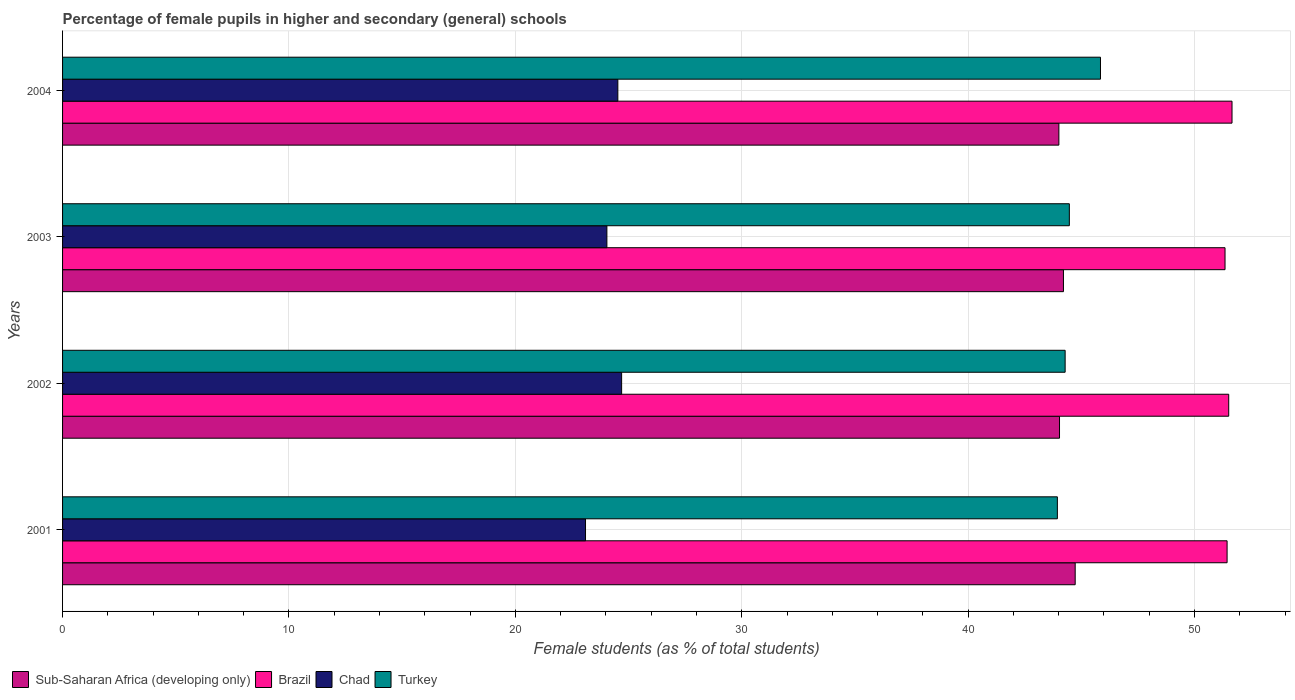How many bars are there on the 2nd tick from the bottom?
Offer a very short reply. 4. What is the percentage of female pupils in higher and secondary schools in Sub-Saharan Africa (developing only) in 2004?
Ensure brevity in your answer.  44.01. Across all years, what is the maximum percentage of female pupils in higher and secondary schools in Brazil?
Give a very brief answer. 51.66. Across all years, what is the minimum percentage of female pupils in higher and secondary schools in Chad?
Offer a very short reply. 23.1. In which year was the percentage of female pupils in higher and secondary schools in Turkey maximum?
Provide a succinct answer. 2004. What is the total percentage of female pupils in higher and secondary schools in Chad in the graph?
Your response must be concise. 96.37. What is the difference between the percentage of female pupils in higher and secondary schools in Turkey in 2002 and that in 2003?
Offer a terse response. -0.19. What is the difference between the percentage of female pupils in higher and secondary schools in Sub-Saharan Africa (developing only) in 2001 and the percentage of female pupils in higher and secondary schools in Brazil in 2003?
Your answer should be compact. -6.62. What is the average percentage of female pupils in higher and secondary schools in Brazil per year?
Your response must be concise. 51.49. In the year 2004, what is the difference between the percentage of female pupils in higher and secondary schools in Turkey and percentage of female pupils in higher and secondary schools in Brazil?
Ensure brevity in your answer.  -5.81. In how many years, is the percentage of female pupils in higher and secondary schools in Brazil greater than 2 %?
Give a very brief answer. 4. What is the ratio of the percentage of female pupils in higher and secondary schools in Brazil in 2003 to that in 2004?
Your answer should be compact. 0.99. Is the percentage of female pupils in higher and secondary schools in Turkey in 2001 less than that in 2002?
Your answer should be compact. Yes. Is the difference between the percentage of female pupils in higher and secondary schools in Turkey in 2002 and 2003 greater than the difference between the percentage of female pupils in higher and secondary schools in Brazil in 2002 and 2003?
Your answer should be compact. No. What is the difference between the highest and the second highest percentage of female pupils in higher and secondary schools in Chad?
Your answer should be compact. 0.17. What is the difference between the highest and the lowest percentage of female pupils in higher and secondary schools in Sub-Saharan Africa (developing only)?
Offer a terse response. 0.72. Is the sum of the percentage of female pupils in higher and secondary schools in Chad in 2002 and 2003 greater than the maximum percentage of female pupils in higher and secondary schools in Brazil across all years?
Keep it short and to the point. No. Is it the case that in every year, the sum of the percentage of female pupils in higher and secondary schools in Sub-Saharan Africa (developing only) and percentage of female pupils in higher and secondary schools in Turkey is greater than the sum of percentage of female pupils in higher and secondary schools in Chad and percentage of female pupils in higher and secondary schools in Brazil?
Your answer should be compact. No. What does the 2nd bar from the top in 2001 represents?
Offer a very short reply. Chad. What does the 4th bar from the bottom in 2003 represents?
Your answer should be very brief. Turkey. Is it the case that in every year, the sum of the percentage of female pupils in higher and secondary schools in Chad and percentage of female pupils in higher and secondary schools in Turkey is greater than the percentage of female pupils in higher and secondary schools in Brazil?
Keep it short and to the point. Yes. What is the difference between two consecutive major ticks on the X-axis?
Ensure brevity in your answer.  10. Does the graph contain any zero values?
Provide a short and direct response. No. Does the graph contain grids?
Provide a short and direct response. Yes. What is the title of the graph?
Give a very brief answer. Percentage of female pupils in higher and secondary (general) schools. What is the label or title of the X-axis?
Make the answer very short. Female students (as % of total students). What is the label or title of the Y-axis?
Provide a short and direct response. Years. What is the Female students (as % of total students) of Sub-Saharan Africa (developing only) in 2001?
Give a very brief answer. 44.73. What is the Female students (as % of total students) in Brazil in 2001?
Provide a short and direct response. 51.44. What is the Female students (as % of total students) in Chad in 2001?
Make the answer very short. 23.1. What is the Female students (as % of total students) in Turkey in 2001?
Give a very brief answer. 43.94. What is the Female students (as % of total students) of Sub-Saharan Africa (developing only) in 2002?
Your answer should be very brief. 44.04. What is the Female students (as % of total students) of Brazil in 2002?
Provide a short and direct response. 51.51. What is the Female students (as % of total students) in Chad in 2002?
Ensure brevity in your answer.  24.69. What is the Female students (as % of total students) in Turkey in 2002?
Make the answer very short. 44.29. What is the Female students (as % of total students) of Sub-Saharan Africa (developing only) in 2003?
Provide a succinct answer. 44.21. What is the Female students (as % of total students) in Brazil in 2003?
Your answer should be compact. 51.35. What is the Female students (as % of total students) of Chad in 2003?
Your answer should be compact. 24.04. What is the Female students (as % of total students) in Turkey in 2003?
Your answer should be very brief. 44.47. What is the Female students (as % of total students) of Sub-Saharan Africa (developing only) in 2004?
Make the answer very short. 44.01. What is the Female students (as % of total students) in Brazil in 2004?
Your answer should be very brief. 51.66. What is the Female students (as % of total students) of Chad in 2004?
Your answer should be very brief. 24.53. What is the Female students (as % of total students) in Turkey in 2004?
Provide a succinct answer. 45.85. Across all years, what is the maximum Female students (as % of total students) in Sub-Saharan Africa (developing only)?
Keep it short and to the point. 44.73. Across all years, what is the maximum Female students (as % of total students) of Brazil?
Keep it short and to the point. 51.66. Across all years, what is the maximum Female students (as % of total students) in Chad?
Your response must be concise. 24.69. Across all years, what is the maximum Female students (as % of total students) in Turkey?
Offer a terse response. 45.85. Across all years, what is the minimum Female students (as % of total students) in Sub-Saharan Africa (developing only)?
Give a very brief answer. 44.01. Across all years, what is the minimum Female students (as % of total students) of Brazil?
Provide a short and direct response. 51.35. Across all years, what is the minimum Female students (as % of total students) in Chad?
Ensure brevity in your answer.  23.1. Across all years, what is the minimum Female students (as % of total students) in Turkey?
Make the answer very short. 43.94. What is the total Female students (as % of total students) in Sub-Saharan Africa (developing only) in the graph?
Ensure brevity in your answer.  176.99. What is the total Female students (as % of total students) in Brazil in the graph?
Your answer should be compact. 205.96. What is the total Female students (as % of total students) in Chad in the graph?
Your answer should be very brief. 96.37. What is the total Female students (as % of total students) of Turkey in the graph?
Ensure brevity in your answer.  178.55. What is the difference between the Female students (as % of total students) of Sub-Saharan Africa (developing only) in 2001 and that in 2002?
Ensure brevity in your answer.  0.69. What is the difference between the Female students (as % of total students) of Brazil in 2001 and that in 2002?
Ensure brevity in your answer.  -0.07. What is the difference between the Female students (as % of total students) of Chad in 2001 and that in 2002?
Provide a short and direct response. -1.59. What is the difference between the Female students (as % of total students) of Turkey in 2001 and that in 2002?
Provide a short and direct response. -0.34. What is the difference between the Female students (as % of total students) of Sub-Saharan Africa (developing only) in 2001 and that in 2003?
Your answer should be very brief. 0.52. What is the difference between the Female students (as % of total students) of Brazil in 2001 and that in 2003?
Your response must be concise. 0.09. What is the difference between the Female students (as % of total students) of Chad in 2001 and that in 2003?
Keep it short and to the point. -0.94. What is the difference between the Female students (as % of total students) in Turkey in 2001 and that in 2003?
Your answer should be compact. -0.53. What is the difference between the Female students (as % of total students) of Sub-Saharan Africa (developing only) in 2001 and that in 2004?
Make the answer very short. 0.72. What is the difference between the Female students (as % of total students) in Brazil in 2001 and that in 2004?
Offer a very short reply. -0.22. What is the difference between the Female students (as % of total students) of Chad in 2001 and that in 2004?
Give a very brief answer. -1.43. What is the difference between the Female students (as % of total students) in Turkey in 2001 and that in 2004?
Your response must be concise. -1.9. What is the difference between the Female students (as % of total students) in Sub-Saharan Africa (developing only) in 2002 and that in 2003?
Your answer should be very brief. -0.17. What is the difference between the Female students (as % of total students) of Brazil in 2002 and that in 2003?
Offer a very short reply. 0.16. What is the difference between the Female students (as % of total students) in Chad in 2002 and that in 2003?
Offer a very short reply. 0.65. What is the difference between the Female students (as % of total students) in Turkey in 2002 and that in 2003?
Offer a terse response. -0.19. What is the difference between the Female students (as % of total students) in Sub-Saharan Africa (developing only) in 2002 and that in 2004?
Offer a terse response. 0.03. What is the difference between the Female students (as % of total students) in Brazil in 2002 and that in 2004?
Offer a very short reply. -0.15. What is the difference between the Female students (as % of total students) in Chad in 2002 and that in 2004?
Offer a terse response. 0.17. What is the difference between the Female students (as % of total students) in Turkey in 2002 and that in 2004?
Your response must be concise. -1.56. What is the difference between the Female students (as % of total students) of Sub-Saharan Africa (developing only) in 2003 and that in 2004?
Provide a short and direct response. 0.2. What is the difference between the Female students (as % of total students) in Brazil in 2003 and that in 2004?
Keep it short and to the point. -0.31. What is the difference between the Female students (as % of total students) of Chad in 2003 and that in 2004?
Your answer should be very brief. -0.48. What is the difference between the Female students (as % of total students) in Turkey in 2003 and that in 2004?
Your answer should be compact. -1.38. What is the difference between the Female students (as % of total students) in Sub-Saharan Africa (developing only) in 2001 and the Female students (as % of total students) in Brazil in 2002?
Your response must be concise. -6.78. What is the difference between the Female students (as % of total students) of Sub-Saharan Africa (developing only) in 2001 and the Female students (as % of total students) of Chad in 2002?
Give a very brief answer. 20.04. What is the difference between the Female students (as % of total students) in Sub-Saharan Africa (developing only) in 2001 and the Female students (as % of total students) in Turkey in 2002?
Keep it short and to the point. 0.44. What is the difference between the Female students (as % of total students) of Brazil in 2001 and the Female students (as % of total students) of Chad in 2002?
Your answer should be compact. 26.75. What is the difference between the Female students (as % of total students) of Brazil in 2001 and the Female students (as % of total students) of Turkey in 2002?
Provide a short and direct response. 7.15. What is the difference between the Female students (as % of total students) in Chad in 2001 and the Female students (as % of total students) in Turkey in 2002?
Your answer should be very brief. -21.19. What is the difference between the Female students (as % of total students) in Sub-Saharan Africa (developing only) in 2001 and the Female students (as % of total students) in Brazil in 2003?
Provide a short and direct response. -6.62. What is the difference between the Female students (as % of total students) in Sub-Saharan Africa (developing only) in 2001 and the Female students (as % of total students) in Chad in 2003?
Keep it short and to the point. 20.69. What is the difference between the Female students (as % of total students) of Sub-Saharan Africa (developing only) in 2001 and the Female students (as % of total students) of Turkey in 2003?
Your response must be concise. 0.26. What is the difference between the Female students (as % of total students) of Brazil in 2001 and the Female students (as % of total students) of Chad in 2003?
Provide a succinct answer. 27.4. What is the difference between the Female students (as % of total students) of Brazil in 2001 and the Female students (as % of total students) of Turkey in 2003?
Your response must be concise. 6.97. What is the difference between the Female students (as % of total students) of Chad in 2001 and the Female students (as % of total students) of Turkey in 2003?
Your response must be concise. -21.37. What is the difference between the Female students (as % of total students) of Sub-Saharan Africa (developing only) in 2001 and the Female students (as % of total students) of Brazil in 2004?
Offer a terse response. -6.93. What is the difference between the Female students (as % of total students) in Sub-Saharan Africa (developing only) in 2001 and the Female students (as % of total students) in Chad in 2004?
Your response must be concise. 20.2. What is the difference between the Female students (as % of total students) of Sub-Saharan Africa (developing only) in 2001 and the Female students (as % of total students) of Turkey in 2004?
Your answer should be very brief. -1.12. What is the difference between the Female students (as % of total students) in Brazil in 2001 and the Female students (as % of total students) in Chad in 2004?
Offer a very short reply. 26.91. What is the difference between the Female students (as % of total students) of Brazil in 2001 and the Female students (as % of total students) of Turkey in 2004?
Offer a terse response. 5.59. What is the difference between the Female students (as % of total students) in Chad in 2001 and the Female students (as % of total students) in Turkey in 2004?
Your response must be concise. -22.75. What is the difference between the Female students (as % of total students) of Sub-Saharan Africa (developing only) in 2002 and the Female students (as % of total students) of Brazil in 2003?
Offer a very short reply. -7.31. What is the difference between the Female students (as % of total students) in Sub-Saharan Africa (developing only) in 2002 and the Female students (as % of total students) in Chad in 2003?
Give a very brief answer. 19.99. What is the difference between the Female students (as % of total students) in Sub-Saharan Africa (developing only) in 2002 and the Female students (as % of total students) in Turkey in 2003?
Make the answer very short. -0.43. What is the difference between the Female students (as % of total students) in Brazil in 2002 and the Female students (as % of total students) in Chad in 2003?
Your answer should be compact. 27.47. What is the difference between the Female students (as % of total students) of Brazil in 2002 and the Female students (as % of total students) of Turkey in 2003?
Keep it short and to the point. 7.04. What is the difference between the Female students (as % of total students) in Chad in 2002 and the Female students (as % of total students) in Turkey in 2003?
Provide a succinct answer. -19.78. What is the difference between the Female students (as % of total students) of Sub-Saharan Africa (developing only) in 2002 and the Female students (as % of total students) of Brazil in 2004?
Your answer should be very brief. -7.62. What is the difference between the Female students (as % of total students) in Sub-Saharan Africa (developing only) in 2002 and the Female students (as % of total students) in Chad in 2004?
Your response must be concise. 19.51. What is the difference between the Female students (as % of total students) in Sub-Saharan Africa (developing only) in 2002 and the Female students (as % of total students) in Turkey in 2004?
Offer a very short reply. -1.81. What is the difference between the Female students (as % of total students) of Brazil in 2002 and the Female students (as % of total students) of Chad in 2004?
Give a very brief answer. 26.98. What is the difference between the Female students (as % of total students) in Brazil in 2002 and the Female students (as % of total students) in Turkey in 2004?
Keep it short and to the point. 5.66. What is the difference between the Female students (as % of total students) of Chad in 2002 and the Female students (as % of total students) of Turkey in 2004?
Your answer should be very brief. -21.15. What is the difference between the Female students (as % of total students) in Sub-Saharan Africa (developing only) in 2003 and the Female students (as % of total students) in Brazil in 2004?
Give a very brief answer. -7.45. What is the difference between the Female students (as % of total students) of Sub-Saharan Africa (developing only) in 2003 and the Female students (as % of total students) of Chad in 2004?
Provide a succinct answer. 19.68. What is the difference between the Female students (as % of total students) in Sub-Saharan Africa (developing only) in 2003 and the Female students (as % of total students) in Turkey in 2004?
Make the answer very short. -1.64. What is the difference between the Female students (as % of total students) in Brazil in 2003 and the Female students (as % of total students) in Chad in 2004?
Provide a short and direct response. 26.82. What is the difference between the Female students (as % of total students) in Brazil in 2003 and the Female students (as % of total students) in Turkey in 2004?
Keep it short and to the point. 5.5. What is the difference between the Female students (as % of total students) in Chad in 2003 and the Female students (as % of total students) in Turkey in 2004?
Offer a terse response. -21.8. What is the average Female students (as % of total students) in Sub-Saharan Africa (developing only) per year?
Offer a terse response. 44.25. What is the average Female students (as % of total students) in Brazil per year?
Your answer should be very brief. 51.49. What is the average Female students (as % of total students) of Chad per year?
Provide a succinct answer. 24.09. What is the average Female students (as % of total students) of Turkey per year?
Provide a succinct answer. 44.64. In the year 2001, what is the difference between the Female students (as % of total students) in Sub-Saharan Africa (developing only) and Female students (as % of total students) in Brazil?
Your answer should be compact. -6.71. In the year 2001, what is the difference between the Female students (as % of total students) in Sub-Saharan Africa (developing only) and Female students (as % of total students) in Chad?
Make the answer very short. 21.63. In the year 2001, what is the difference between the Female students (as % of total students) in Sub-Saharan Africa (developing only) and Female students (as % of total students) in Turkey?
Keep it short and to the point. 0.79. In the year 2001, what is the difference between the Female students (as % of total students) of Brazil and Female students (as % of total students) of Chad?
Your answer should be compact. 28.34. In the year 2001, what is the difference between the Female students (as % of total students) of Brazil and Female students (as % of total students) of Turkey?
Your response must be concise. 7.5. In the year 2001, what is the difference between the Female students (as % of total students) of Chad and Female students (as % of total students) of Turkey?
Ensure brevity in your answer.  -20.84. In the year 2002, what is the difference between the Female students (as % of total students) in Sub-Saharan Africa (developing only) and Female students (as % of total students) in Brazil?
Make the answer very short. -7.47. In the year 2002, what is the difference between the Female students (as % of total students) of Sub-Saharan Africa (developing only) and Female students (as % of total students) of Chad?
Keep it short and to the point. 19.34. In the year 2002, what is the difference between the Female students (as % of total students) of Sub-Saharan Africa (developing only) and Female students (as % of total students) of Turkey?
Offer a terse response. -0.25. In the year 2002, what is the difference between the Female students (as % of total students) in Brazil and Female students (as % of total students) in Chad?
Your answer should be very brief. 26.82. In the year 2002, what is the difference between the Female students (as % of total students) in Brazil and Female students (as % of total students) in Turkey?
Keep it short and to the point. 7.23. In the year 2002, what is the difference between the Female students (as % of total students) in Chad and Female students (as % of total students) in Turkey?
Your response must be concise. -19.59. In the year 2003, what is the difference between the Female students (as % of total students) of Sub-Saharan Africa (developing only) and Female students (as % of total students) of Brazil?
Give a very brief answer. -7.14. In the year 2003, what is the difference between the Female students (as % of total students) in Sub-Saharan Africa (developing only) and Female students (as % of total students) in Chad?
Your response must be concise. 20.17. In the year 2003, what is the difference between the Female students (as % of total students) of Sub-Saharan Africa (developing only) and Female students (as % of total students) of Turkey?
Your response must be concise. -0.26. In the year 2003, what is the difference between the Female students (as % of total students) in Brazil and Female students (as % of total students) in Chad?
Make the answer very short. 27.3. In the year 2003, what is the difference between the Female students (as % of total students) in Brazil and Female students (as % of total students) in Turkey?
Give a very brief answer. 6.88. In the year 2003, what is the difference between the Female students (as % of total students) in Chad and Female students (as % of total students) in Turkey?
Offer a very short reply. -20.43. In the year 2004, what is the difference between the Female students (as % of total students) of Sub-Saharan Africa (developing only) and Female students (as % of total students) of Brazil?
Make the answer very short. -7.65. In the year 2004, what is the difference between the Female students (as % of total students) in Sub-Saharan Africa (developing only) and Female students (as % of total students) in Chad?
Your answer should be compact. 19.48. In the year 2004, what is the difference between the Female students (as % of total students) of Sub-Saharan Africa (developing only) and Female students (as % of total students) of Turkey?
Provide a succinct answer. -1.84. In the year 2004, what is the difference between the Female students (as % of total students) of Brazil and Female students (as % of total students) of Chad?
Your answer should be compact. 27.13. In the year 2004, what is the difference between the Female students (as % of total students) of Brazil and Female students (as % of total students) of Turkey?
Keep it short and to the point. 5.81. In the year 2004, what is the difference between the Female students (as % of total students) in Chad and Female students (as % of total students) in Turkey?
Ensure brevity in your answer.  -21.32. What is the ratio of the Female students (as % of total students) in Sub-Saharan Africa (developing only) in 2001 to that in 2002?
Your response must be concise. 1.02. What is the ratio of the Female students (as % of total students) in Brazil in 2001 to that in 2002?
Make the answer very short. 1. What is the ratio of the Female students (as % of total students) in Chad in 2001 to that in 2002?
Ensure brevity in your answer.  0.94. What is the ratio of the Female students (as % of total students) of Sub-Saharan Africa (developing only) in 2001 to that in 2003?
Your response must be concise. 1.01. What is the ratio of the Female students (as % of total students) of Brazil in 2001 to that in 2003?
Offer a very short reply. 1. What is the ratio of the Female students (as % of total students) in Chad in 2001 to that in 2003?
Ensure brevity in your answer.  0.96. What is the ratio of the Female students (as % of total students) of Turkey in 2001 to that in 2003?
Give a very brief answer. 0.99. What is the ratio of the Female students (as % of total students) in Sub-Saharan Africa (developing only) in 2001 to that in 2004?
Provide a short and direct response. 1.02. What is the ratio of the Female students (as % of total students) of Chad in 2001 to that in 2004?
Give a very brief answer. 0.94. What is the ratio of the Female students (as % of total students) in Turkey in 2001 to that in 2004?
Your answer should be very brief. 0.96. What is the ratio of the Female students (as % of total students) of Brazil in 2002 to that in 2003?
Your answer should be very brief. 1. What is the ratio of the Female students (as % of total students) in Chad in 2002 to that in 2003?
Give a very brief answer. 1.03. What is the ratio of the Female students (as % of total students) in Turkey in 2002 to that in 2003?
Provide a short and direct response. 1. What is the ratio of the Female students (as % of total students) of Chad in 2002 to that in 2004?
Make the answer very short. 1.01. What is the ratio of the Female students (as % of total students) of Turkey in 2002 to that in 2004?
Offer a very short reply. 0.97. What is the ratio of the Female students (as % of total students) of Sub-Saharan Africa (developing only) in 2003 to that in 2004?
Offer a very short reply. 1. What is the ratio of the Female students (as % of total students) of Brazil in 2003 to that in 2004?
Keep it short and to the point. 0.99. What is the ratio of the Female students (as % of total students) of Chad in 2003 to that in 2004?
Keep it short and to the point. 0.98. What is the ratio of the Female students (as % of total students) in Turkey in 2003 to that in 2004?
Your answer should be compact. 0.97. What is the difference between the highest and the second highest Female students (as % of total students) in Sub-Saharan Africa (developing only)?
Give a very brief answer. 0.52. What is the difference between the highest and the second highest Female students (as % of total students) in Brazil?
Offer a very short reply. 0.15. What is the difference between the highest and the second highest Female students (as % of total students) of Chad?
Ensure brevity in your answer.  0.17. What is the difference between the highest and the second highest Female students (as % of total students) in Turkey?
Give a very brief answer. 1.38. What is the difference between the highest and the lowest Female students (as % of total students) of Sub-Saharan Africa (developing only)?
Keep it short and to the point. 0.72. What is the difference between the highest and the lowest Female students (as % of total students) of Brazil?
Your response must be concise. 0.31. What is the difference between the highest and the lowest Female students (as % of total students) of Chad?
Provide a succinct answer. 1.59. What is the difference between the highest and the lowest Female students (as % of total students) in Turkey?
Your answer should be compact. 1.9. 